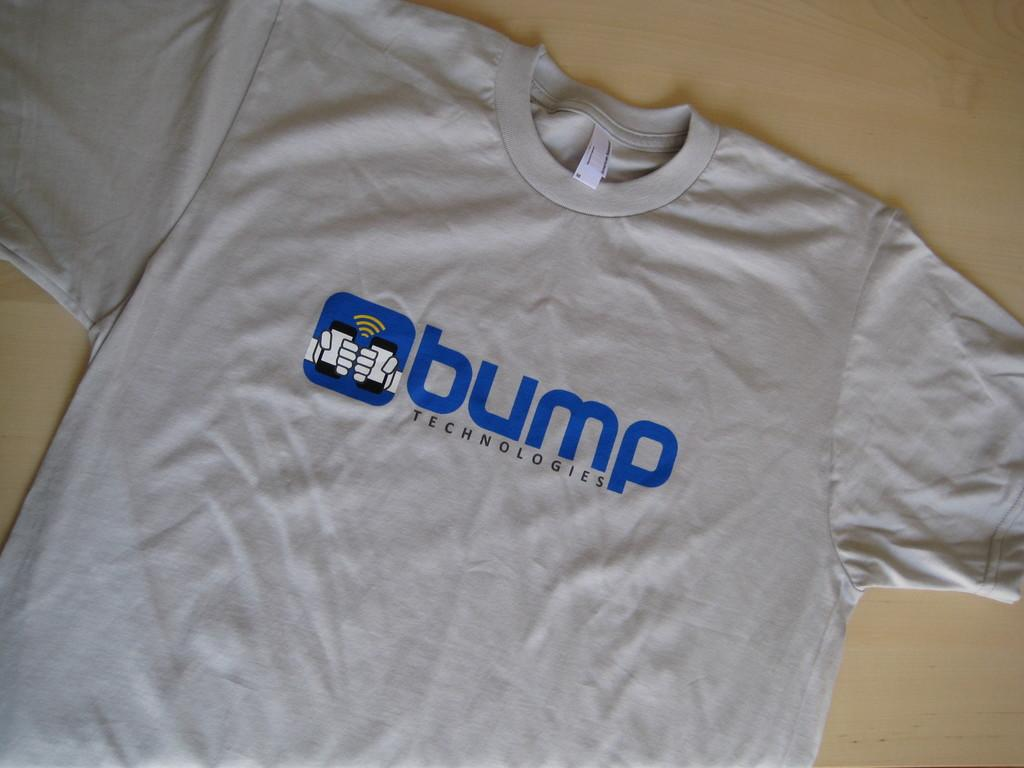<image>
Summarize the visual content of the image. a grey tshirt with the word bump on it 